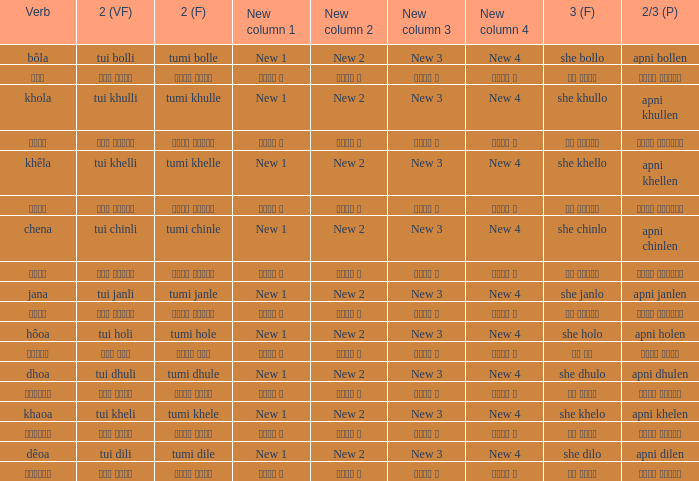Parse the full table. {'header': ['Verb', '2 (VF)', '2 (F)', 'New column 1', 'New column 2', 'New column 3', 'New column 4', '3 (F)', '2/3 (P)'], 'rows': [['bôla', 'tui bolli', 'tumi bolle', 'New 1', 'New 2', 'New 3', 'New 4', 'she bollo', 'apni bollen'], ['বলা', 'তুই বললি', 'তুমি বললে', 'নতুন ১', 'নতুন ২', 'নতুন ৩', 'নতুন ৪', 'সে বললো', 'আপনি বললেন'], ['khola', 'tui khulli', 'tumi khulle', 'New 1', 'New 2', 'New 3', 'New 4', 'she khullo', 'apni khullen'], ['খোলা', 'তুই খুললি', 'তুমি খুললে', 'নতুন ১', 'নতুন ২', 'নতুন ৩', 'নতুন ৪', 'সে খুললো', 'আপনি খুললেন'], ['khêla', 'tui khelli', 'tumi khelle', 'New 1', 'New 2', 'New 3', 'New 4', 'she khello', 'apni khellen'], ['খেলে', 'তুই খেললি', 'তুমি খেললে', 'নতুন ১', 'নতুন ২', 'নতুন ৩', 'নতুন ৪', 'সে খেললো', 'আপনি খেললেন'], ['chena', 'tui chinli', 'tumi chinle', 'New 1', 'New 2', 'New 3', 'New 4', 'she chinlo', 'apni chinlen'], ['চেনা', 'তুই চিনলি', 'তুমি চিনলে', 'নতুন ১', 'নতুন ২', 'নতুন ৩', 'নতুন ৪', 'সে চিনলো', 'আপনি চিনলেন'], ['jana', 'tui janli', 'tumi janle', 'New 1', 'New 2', 'New 3', 'New 4', 'she janlo', 'apni janlen'], ['জানা', 'তুই জানলি', 'তুমি জানলে', 'নতুন ১', 'নতুন ২', 'নতুন ৩', 'নতুন ৪', 'সে জানলে', 'আপনি জানলেন'], ['hôoa', 'tui holi', 'tumi hole', 'New 1', 'New 2', 'New 3', 'New 4', 'she holo', 'apni holen'], ['হওয়া', 'তুই হলি', 'তুমি হলে', 'নতুন ১', 'নতুন ২', 'নতুন ৩', 'নতুন ৪', 'সে হল', 'আপনি হলেন'], ['dhoa', 'tui dhuli', 'tumi dhule', 'New 1', 'New 2', 'New 3', 'New 4', 'she dhulo', 'apni dhulen'], ['ধোওয়া', 'তুই ধুলি', 'তুমি ধুলে', 'নতুন ১', 'নতুন ২', 'নতুন ৩', 'নতুন ৪', 'সে ধুলো', 'আপনি ধুলেন'], ['khaoa', 'tui kheli', 'tumi khele', 'New 1', 'New 2', 'New 3', 'New 4', 'she khelo', 'apni khelen'], ['খাওয়া', 'তুই খেলি', 'তুমি খেলে', 'নতুন ১', 'নতুন ২', 'নতুন ৩', 'নতুন ৪', 'সে খেলো', 'আপনি খেলেন'], ['dêoa', 'tui dili', 'tumi dile', 'New 1', 'New 2', 'New 3', 'New 4', 'she dilo', 'apni dilen'], ['দেওয়া', 'তুই দিলি', 'তুমি দিলে', 'নতুন ১', 'নতুন ২', 'নতুন ৩', 'নতুন ৪', 'সে দিলো', 'আপনি দিলেন']]} What is the third for the second tui dhuli? She dhulo. 